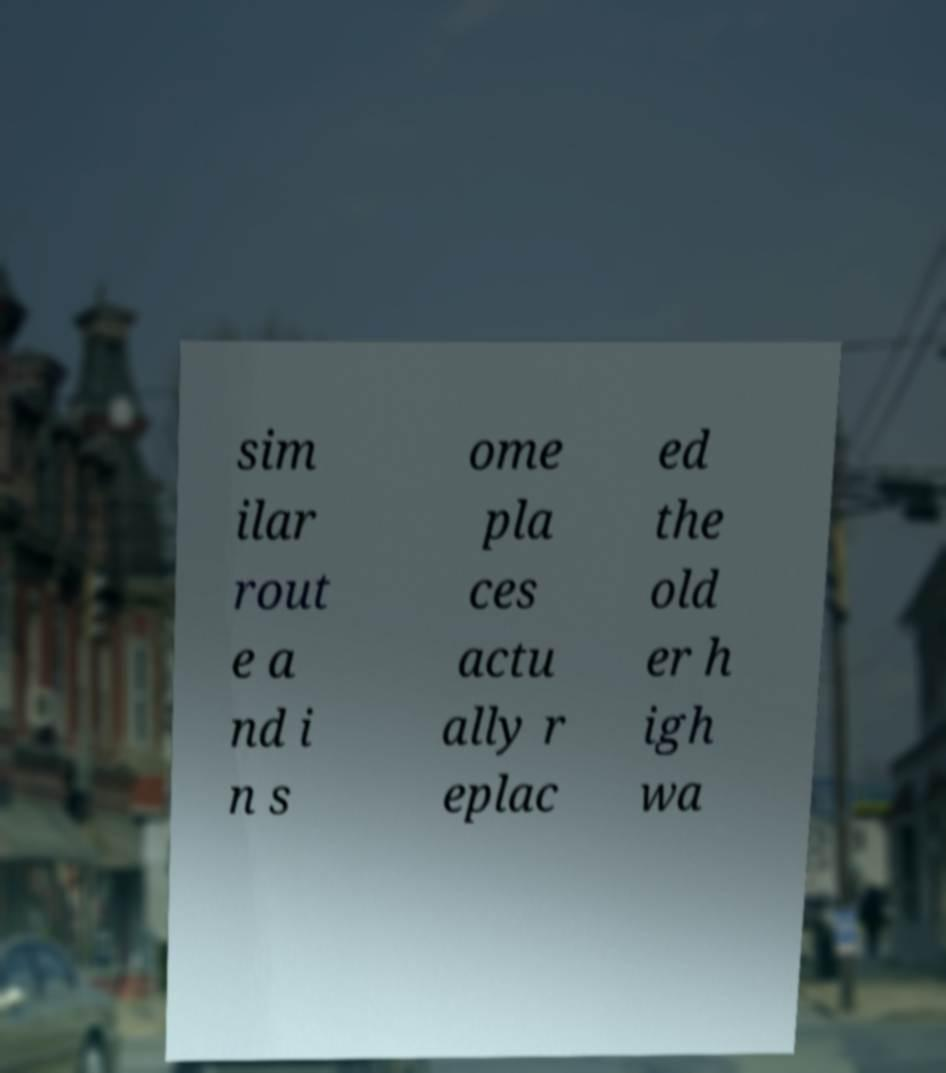Could you extract and type out the text from this image? sim ilar rout e a nd i n s ome pla ces actu ally r eplac ed the old er h igh wa 